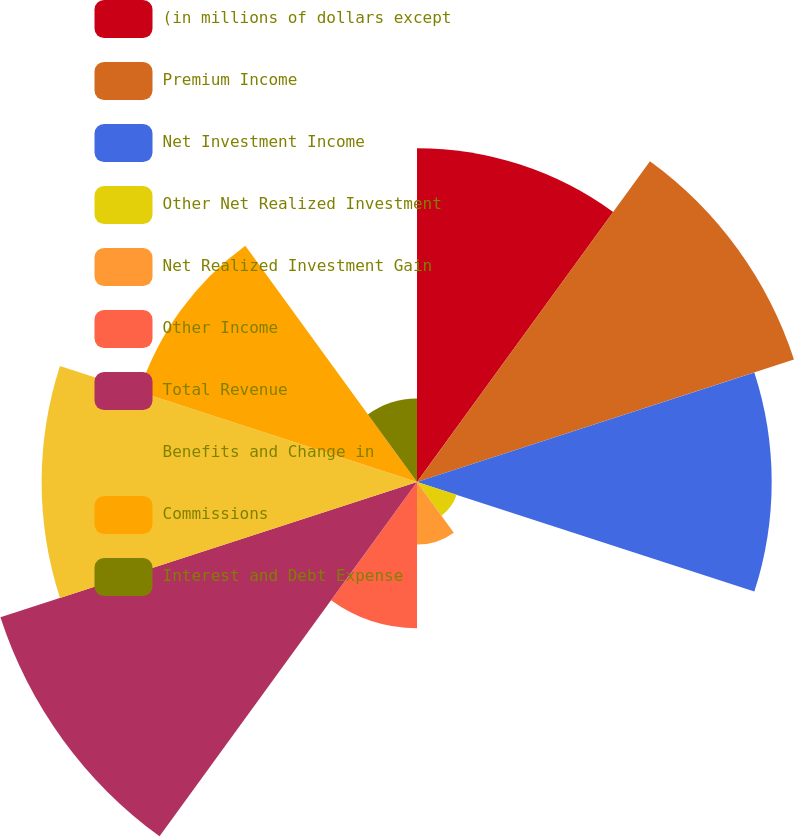Convert chart. <chart><loc_0><loc_0><loc_500><loc_500><pie_chart><fcel>(in millions of dollars except<fcel>Premium Income<fcel>Net Investment Income<fcel>Other Net Realized Investment<fcel>Net Realized Investment Gain<fcel>Other Income<fcel>Total Revenue<fcel>Benefits and Change in<fcel>Commissions<fcel>Interest and Debt Expense<nl><fcel>13.22%<fcel>15.7%<fcel>14.05%<fcel>1.65%<fcel>2.48%<fcel>5.79%<fcel>17.35%<fcel>14.87%<fcel>11.57%<fcel>3.31%<nl></chart> 